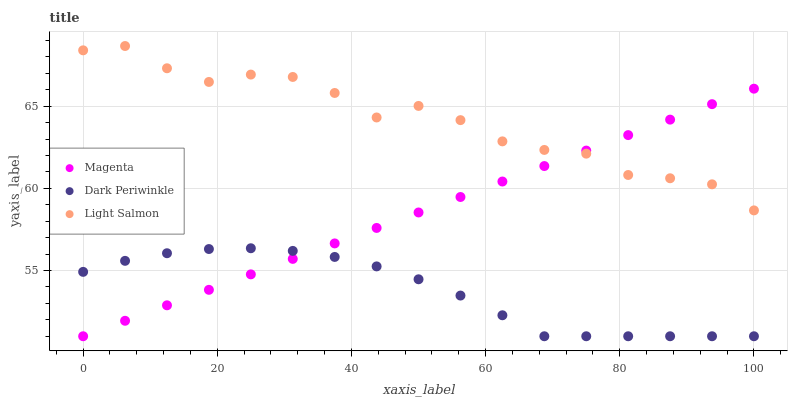Does Dark Periwinkle have the minimum area under the curve?
Answer yes or no. Yes. Does Light Salmon have the maximum area under the curve?
Answer yes or no. Yes. Does Light Salmon have the minimum area under the curve?
Answer yes or no. No. Does Dark Periwinkle have the maximum area under the curve?
Answer yes or no. No. Is Magenta the smoothest?
Answer yes or no. Yes. Is Light Salmon the roughest?
Answer yes or no. Yes. Is Dark Periwinkle the smoothest?
Answer yes or no. No. Is Dark Periwinkle the roughest?
Answer yes or no. No. Does Magenta have the lowest value?
Answer yes or no. Yes. Does Light Salmon have the lowest value?
Answer yes or no. No. Does Light Salmon have the highest value?
Answer yes or no. Yes. Does Dark Periwinkle have the highest value?
Answer yes or no. No. Is Dark Periwinkle less than Light Salmon?
Answer yes or no. Yes. Is Light Salmon greater than Dark Periwinkle?
Answer yes or no. Yes. Does Magenta intersect Light Salmon?
Answer yes or no. Yes. Is Magenta less than Light Salmon?
Answer yes or no. No. Is Magenta greater than Light Salmon?
Answer yes or no. No. Does Dark Periwinkle intersect Light Salmon?
Answer yes or no. No. 